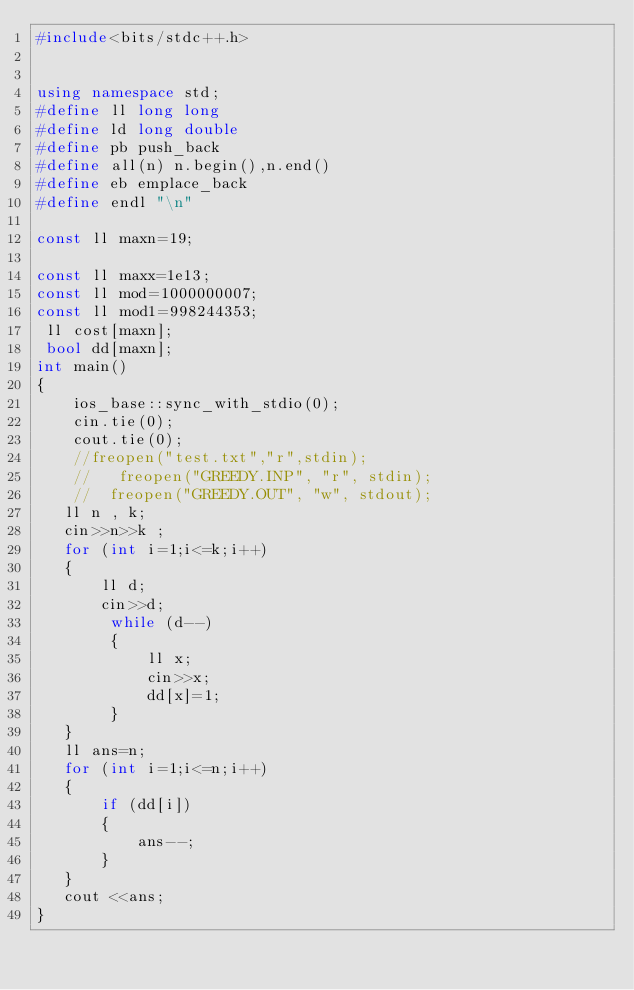<code> <loc_0><loc_0><loc_500><loc_500><_C++_>#include<bits/stdc++.h>


using namespace std;
#define ll long long
#define ld long double
#define pb push_back
#define all(n) n.begin(),n.end()
#define eb emplace_back
#define endl "\n"

const ll maxn=19;

const ll maxx=1e13;
const ll mod=1000000007;
const ll mod1=998244353;
 ll cost[maxn];
 bool dd[maxn];
int main()
{
    ios_base::sync_with_stdio(0);
    cin.tie(0);
    cout.tie(0);
    //freopen("test.txt","r",stdin);
    //   freopen("GREEDY.INP", "r", stdin);
    //  freopen("GREEDY.OUT", "w", stdout);
   ll n , k;
   cin>>n>>k ;
   for (int i=1;i<=k;i++)
   {
       ll d;
       cin>>d;
        while (d--)
        {
            ll x;
            cin>>x;
            dd[x]=1;
        }
   }
   ll ans=n;
   for (int i=1;i<=n;i++)
   {
       if (dd[i])
       {
           ans--;
       }
   }
   cout <<ans;
}
</code> 